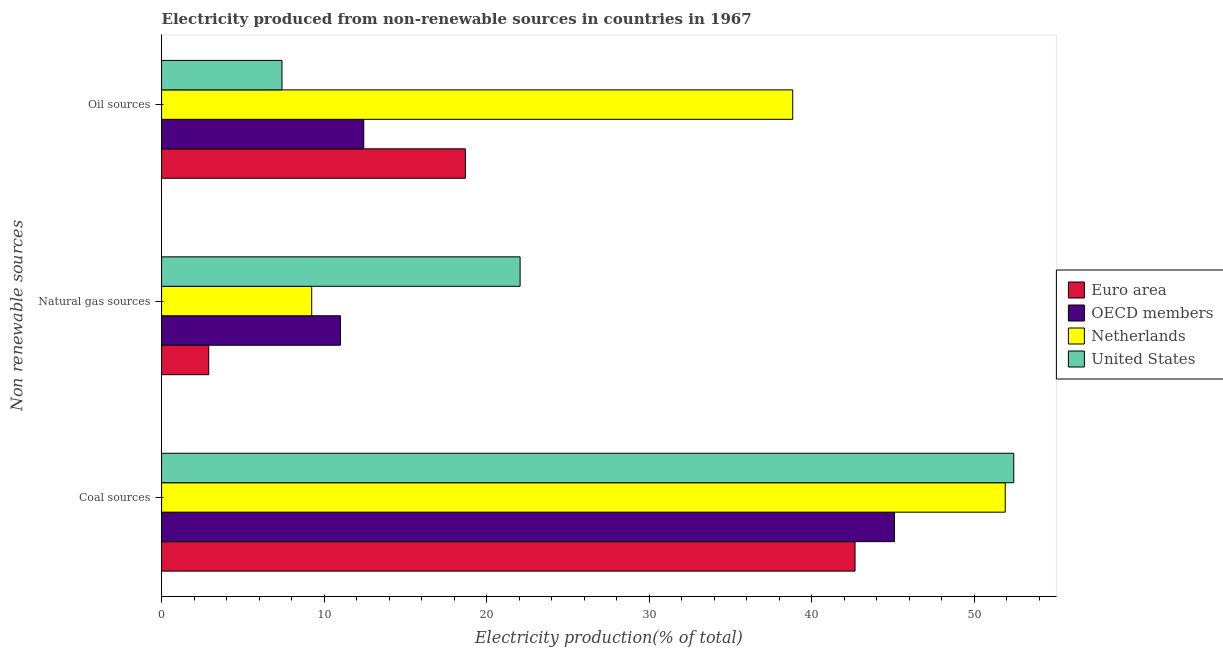How many different coloured bars are there?
Offer a terse response. 4. What is the label of the 2nd group of bars from the top?
Keep it short and to the point. Natural gas sources. What is the percentage of electricity produced by oil sources in OECD members?
Provide a succinct answer. 12.44. Across all countries, what is the maximum percentage of electricity produced by coal?
Provide a short and direct response. 52.45. Across all countries, what is the minimum percentage of electricity produced by oil sources?
Your answer should be compact. 7.41. What is the total percentage of electricity produced by oil sources in the graph?
Offer a terse response. 77.39. What is the difference between the percentage of electricity produced by natural gas in Netherlands and that in Euro area?
Your answer should be compact. 6.34. What is the difference between the percentage of electricity produced by coal in Netherlands and the percentage of electricity produced by oil sources in OECD members?
Give a very brief answer. 39.48. What is the average percentage of electricity produced by natural gas per country?
Your answer should be compact. 11.3. What is the difference between the percentage of electricity produced by oil sources and percentage of electricity produced by natural gas in Euro area?
Keep it short and to the point. 15.8. What is the ratio of the percentage of electricity produced by coal in Euro area to that in Netherlands?
Your answer should be compact. 0.82. Is the percentage of electricity produced by natural gas in United States less than that in Netherlands?
Provide a short and direct response. No. What is the difference between the highest and the second highest percentage of electricity produced by natural gas?
Provide a succinct answer. 11.05. What is the difference between the highest and the lowest percentage of electricity produced by natural gas?
Ensure brevity in your answer.  19.16. In how many countries, is the percentage of electricity produced by natural gas greater than the average percentage of electricity produced by natural gas taken over all countries?
Offer a terse response. 1. Is the sum of the percentage of electricity produced by coal in Euro area and OECD members greater than the maximum percentage of electricity produced by oil sources across all countries?
Keep it short and to the point. Yes. What does the 3rd bar from the top in Coal sources represents?
Offer a very short reply. OECD members. What does the 4th bar from the bottom in Coal sources represents?
Offer a very short reply. United States. How many bars are there?
Your response must be concise. 12. Are all the bars in the graph horizontal?
Your answer should be compact. Yes. How many countries are there in the graph?
Your response must be concise. 4. Does the graph contain any zero values?
Your response must be concise. No. How many legend labels are there?
Ensure brevity in your answer.  4. What is the title of the graph?
Keep it short and to the point. Electricity produced from non-renewable sources in countries in 1967. Does "Czech Republic" appear as one of the legend labels in the graph?
Ensure brevity in your answer.  No. What is the label or title of the Y-axis?
Your answer should be compact. Non renewable sources. What is the Electricity production(% of total) in Euro area in Coal sources?
Give a very brief answer. 42.68. What is the Electricity production(% of total) in OECD members in Coal sources?
Give a very brief answer. 45.1. What is the Electricity production(% of total) in Netherlands in Coal sources?
Your response must be concise. 51.92. What is the Electricity production(% of total) in United States in Coal sources?
Provide a short and direct response. 52.45. What is the Electricity production(% of total) in Euro area in Natural gas sources?
Give a very brief answer. 2.9. What is the Electricity production(% of total) in OECD members in Natural gas sources?
Keep it short and to the point. 11.01. What is the Electricity production(% of total) of Netherlands in Natural gas sources?
Ensure brevity in your answer.  9.24. What is the Electricity production(% of total) of United States in Natural gas sources?
Your answer should be very brief. 22.06. What is the Electricity production(% of total) of Euro area in Oil sources?
Keep it short and to the point. 18.7. What is the Electricity production(% of total) in OECD members in Oil sources?
Your answer should be compact. 12.44. What is the Electricity production(% of total) in Netherlands in Oil sources?
Give a very brief answer. 38.84. What is the Electricity production(% of total) of United States in Oil sources?
Offer a terse response. 7.41. Across all Non renewable sources, what is the maximum Electricity production(% of total) in Euro area?
Give a very brief answer. 42.68. Across all Non renewable sources, what is the maximum Electricity production(% of total) of OECD members?
Offer a very short reply. 45.1. Across all Non renewable sources, what is the maximum Electricity production(% of total) of Netherlands?
Your answer should be compact. 51.92. Across all Non renewable sources, what is the maximum Electricity production(% of total) in United States?
Make the answer very short. 52.45. Across all Non renewable sources, what is the minimum Electricity production(% of total) of Euro area?
Your response must be concise. 2.9. Across all Non renewable sources, what is the minimum Electricity production(% of total) in OECD members?
Provide a succinct answer. 11.01. Across all Non renewable sources, what is the minimum Electricity production(% of total) of Netherlands?
Offer a terse response. 9.24. Across all Non renewable sources, what is the minimum Electricity production(% of total) in United States?
Your response must be concise. 7.41. What is the total Electricity production(% of total) of Euro area in the graph?
Make the answer very short. 64.27. What is the total Electricity production(% of total) in OECD members in the graph?
Provide a short and direct response. 68.56. What is the total Electricity production(% of total) of Netherlands in the graph?
Offer a terse response. 100. What is the total Electricity production(% of total) of United States in the graph?
Offer a very short reply. 81.92. What is the difference between the Electricity production(% of total) of Euro area in Coal sources and that in Natural gas sources?
Make the answer very short. 39.78. What is the difference between the Electricity production(% of total) of OECD members in Coal sources and that in Natural gas sources?
Provide a short and direct response. 34.09. What is the difference between the Electricity production(% of total) in Netherlands in Coal sources and that in Natural gas sources?
Offer a very short reply. 42.68. What is the difference between the Electricity production(% of total) of United States in Coal sources and that in Natural gas sources?
Your response must be concise. 30.38. What is the difference between the Electricity production(% of total) of Euro area in Coal sources and that in Oil sources?
Provide a short and direct response. 23.98. What is the difference between the Electricity production(% of total) in OECD members in Coal sources and that in Oil sources?
Offer a very short reply. 32.66. What is the difference between the Electricity production(% of total) of Netherlands in Coal sources and that in Oil sources?
Make the answer very short. 13.08. What is the difference between the Electricity production(% of total) of United States in Coal sources and that in Oil sources?
Your response must be concise. 45.03. What is the difference between the Electricity production(% of total) in Euro area in Natural gas sources and that in Oil sources?
Provide a succinct answer. -15.8. What is the difference between the Electricity production(% of total) in OECD members in Natural gas sources and that in Oil sources?
Give a very brief answer. -1.43. What is the difference between the Electricity production(% of total) in Netherlands in Natural gas sources and that in Oil sources?
Provide a succinct answer. -29.6. What is the difference between the Electricity production(% of total) in United States in Natural gas sources and that in Oil sources?
Keep it short and to the point. 14.65. What is the difference between the Electricity production(% of total) in Euro area in Coal sources and the Electricity production(% of total) in OECD members in Natural gas sources?
Your answer should be very brief. 31.67. What is the difference between the Electricity production(% of total) in Euro area in Coal sources and the Electricity production(% of total) in Netherlands in Natural gas sources?
Give a very brief answer. 33.44. What is the difference between the Electricity production(% of total) of Euro area in Coal sources and the Electricity production(% of total) of United States in Natural gas sources?
Your answer should be compact. 20.61. What is the difference between the Electricity production(% of total) in OECD members in Coal sources and the Electricity production(% of total) in Netherlands in Natural gas sources?
Ensure brevity in your answer.  35.87. What is the difference between the Electricity production(% of total) in OECD members in Coal sources and the Electricity production(% of total) in United States in Natural gas sources?
Offer a very short reply. 23.04. What is the difference between the Electricity production(% of total) of Netherlands in Coal sources and the Electricity production(% of total) of United States in Natural gas sources?
Make the answer very short. 29.86. What is the difference between the Electricity production(% of total) in Euro area in Coal sources and the Electricity production(% of total) in OECD members in Oil sources?
Your answer should be very brief. 30.23. What is the difference between the Electricity production(% of total) in Euro area in Coal sources and the Electricity production(% of total) in Netherlands in Oil sources?
Make the answer very short. 3.84. What is the difference between the Electricity production(% of total) of Euro area in Coal sources and the Electricity production(% of total) of United States in Oil sources?
Ensure brevity in your answer.  35.27. What is the difference between the Electricity production(% of total) in OECD members in Coal sources and the Electricity production(% of total) in Netherlands in Oil sources?
Your answer should be compact. 6.26. What is the difference between the Electricity production(% of total) of OECD members in Coal sources and the Electricity production(% of total) of United States in Oil sources?
Your answer should be compact. 37.69. What is the difference between the Electricity production(% of total) in Netherlands in Coal sources and the Electricity production(% of total) in United States in Oil sources?
Give a very brief answer. 44.51. What is the difference between the Electricity production(% of total) in Euro area in Natural gas sources and the Electricity production(% of total) in OECD members in Oil sources?
Offer a very short reply. -9.54. What is the difference between the Electricity production(% of total) of Euro area in Natural gas sources and the Electricity production(% of total) of Netherlands in Oil sources?
Give a very brief answer. -35.94. What is the difference between the Electricity production(% of total) in Euro area in Natural gas sources and the Electricity production(% of total) in United States in Oil sources?
Offer a very short reply. -4.51. What is the difference between the Electricity production(% of total) of OECD members in Natural gas sources and the Electricity production(% of total) of Netherlands in Oil sources?
Provide a short and direct response. -27.83. What is the difference between the Electricity production(% of total) in OECD members in Natural gas sources and the Electricity production(% of total) in United States in Oil sources?
Ensure brevity in your answer.  3.6. What is the difference between the Electricity production(% of total) of Netherlands in Natural gas sources and the Electricity production(% of total) of United States in Oil sources?
Your answer should be compact. 1.83. What is the average Electricity production(% of total) of Euro area per Non renewable sources?
Offer a very short reply. 21.42. What is the average Electricity production(% of total) in OECD members per Non renewable sources?
Offer a terse response. 22.85. What is the average Electricity production(% of total) of Netherlands per Non renewable sources?
Make the answer very short. 33.33. What is the average Electricity production(% of total) of United States per Non renewable sources?
Provide a succinct answer. 27.31. What is the difference between the Electricity production(% of total) of Euro area and Electricity production(% of total) of OECD members in Coal sources?
Provide a short and direct response. -2.43. What is the difference between the Electricity production(% of total) of Euro area and Electricity production(% of total) of Netherlands in Coal sources?
Your response must be concise. -9.24. What is the difference between the Electricity production(% of total) in Euro area and Electricity production(% of total) in United States in Coal sources?
Provide a short and direct response. -9.77. What is the difference between the Electricity production(% of total) in OECD members and Electricity production(% of total) in Netherlands in Coal sources?
Make the answer very short. -6.82. What is the difference between the Electricity production(% of total) in OECD members and Electricity production(% of total) in United States in Coal sources?
Make the answer very short. -7.34. What is the difference between the Electricity production(% of total) of Netherlands and Electricity production(% of total) of United States in Coal sources?
Make the answer very short. -0.53. What is the difference between the Electricity production(% of total) of Euro area and Electricity production(% of total) of OECD members in Natural gas sources?
Offer a very short reply. -8.11. What is the difference between the Electricity production(% of total) in Euro area and Electricity production(% of total) in Netherlands in Natural gas sources?
Ensure brevity in your answer.  -6.34. What is the difference between the Electricity production(% of total) of Euro area and Electricity production(% of total) of United States in Natural gas sources?
Offer a very short reply. -19.16. What is the difference between the Electricity production(% of total) in OECD members and Electricity production(% of total) in Netherlands in Natural gas sources?
Offer a very short reply. 1.77. What is the difference between the Electricity production(% of total) in OECD members and Electricity production(% of total) in United States in Natural gas sources?
Your response must be concise. -11.05. What is the difference between the Electricity production(% of total) of Netherlands and Electricity production(% of total) of United States in Natural gas sources?
Your answer should be compact. -12.83. What is the difference between the Electricity production(% of total) in Euro area and Electricity production(% of total) in OECD members in Oil sources?
Offer a very short reply. 6.25. What is the difference between the Electricity production(% of total) of Euro area and Electricity production(% of total) of Netherlands in Oil sources?
Offer a terse response. -20.14. What is the difference between the Electricity production(% of total) of Euro area and Electricity production(% of total) of United States in Oil sources?
Ensure brevity in your answer.  11.29. What is the difference between the Electricity production(% of total) in OECD members and Electricity production(% of total) in Netherlands in Oil sources?
Ensure brevity in your answer.  -26.4. What is the difference between the Electricity production(% of total) of OECD members and Electricity production(% of total) of United States in Oil sources?
Offer a very short reply. 5.03. What is the difference between the Electricity production(% of total) of Netherlands and Electricity production(% of total) of United States in Oil sources?
Your answer should be compact. 31.43. What is the ratio of the Electricity production(% of total) in Euro area in Coal sources to that in Natural gas sources?
Your answer should be very brief. 14.71. What is the ratio of the Electricity production(% of total) in OECD members in Coal sources to that in Natural gas sources?
Give a very brief answer. 4.1. What is the ratio of the Electricity production(% of total) in Netherlands in Coal sources to that in Natural gas sources?
Provide a short and direct response. 5.62. What is the ratio of the Electricity production(% of total) of United States in Coal sources to that in Natural gas sources?
Provide a short and direct response. 2.38. What is the ratio of the Electricity production(% of total) of Euro area in Coal sources to that in Oil sources?
Offer a terse response. 2.28. What is the ratio of the Electricity production(% of total) in OECD members in Coal sources to that in Oil sources?
Your answer should be compact. 3.63. What is the ratio of the Electricity production(% of total) of Netherlands in Coal sources to that in Oil sources?
Ensure brevity in your answer.  1.34. What is the ratio of the Electricity production(% of total) in United States in Coal sources to that in Oil sources?
Make the answer very short. 7.08. What is the ratio of the Electricity production(% of total) of Euro area in Natural gas sources to that in Oil sources?
Keep it short and to the point. 0.16. What is the ratio of the Electricity production(% of total) of OECD members in Natural gas sources to that in Oil sources?
Your answer should be compact. 0.88. What is the ratio of the Electricity production(% of total) of Netherlands in Natural gas sources to that in Oil sources?
Keep it short and to the point. 0.24. What is the ratio of the Electricity production(% of total) in United States in Natural gas sources to that in Oil sources?
Provide a succinct answer. 2.98. What is the difference between the highest and the second highest Electricity production(% of total) in Euro area?
Ensure brevity in your answer.  23.98. What is the difference between the highest and the second highest Electricity production(% of total) of OECD members?
Keep it short and to the point. 32.66. What is the difference between the highest and the second highest Electricity production(% of total) of Netherlands?
Ensure brevity in your answer.  13.08. What is the difference between the highest and the second highest Electricity production(% of total) of United States?
Your answer should be very brief. 30.38. What is the difference between the highest and the lowest Electricity production(% of total) of Euro area?
Your response must be concise. 39.78. What is the difference between the highest and the lowest Electricity production(% of total) of OECD members?
Make the answer very short. 34.09. What is the difference between the highest and the lowest Electricity production(% of total) in Netherlands?
Your answer should be compact. 42.68. What is the difference between the highest and the lowest Electricity production(% of total) of United States?
Your answer should be compact. 45.03. 